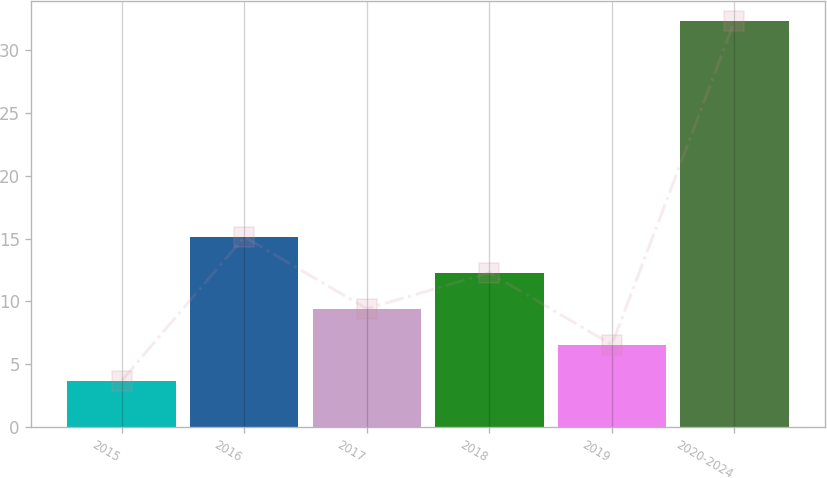Convert chart. <chart><loc_0><loc_0><loc_500><loc_500><bar_chart><fcel>2015<fcel>2016<fcel>2017<fcel>2018<fcel>2019<fcel>2020-2024<nl><fcel>3.7<fcel>15.14<fcel>9.42<fcel>12.28<fcel>6.56<fcel>32.3<nl></chart> 